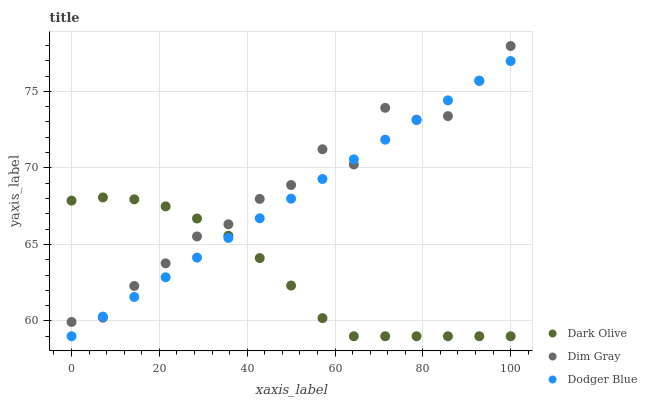Does Dark Olive have the minimum area under the curve?
Answer yes or no. Yes. Does Dim Gray have the maximum area under the curve?
Answer yes or no. Yes. Does Dodger Blue have the minimum area under the curve?
Answer yes or no. No. Does Dodger Blue have the maximum area under the curve?
Answer yes or no. No. Is Dodger Blue the smoothest?
Answer yes or no. Yes. Is Dim Gray the roughest?
Answer yes or no. Yes. Is Dark Olive the smoothest?
Answer yes or no. No. Is Dark Olive the roughest?
Answer yes or no. No. Does Dark Olive have the lowest value?
Answer yes or no. Yes. Does Dim Gray have the highest value?
Answer yes or no. Yes. Does Dodger Blue have the highest value?
Answer yes or no. No. Does Dark Olive intersect Dim Gray?
Answer yes or no. Yes. Is Dark Olive less than Dim Gray?
Answer yes or no. No. Is Dark Olive greater than Dim Gray?
Answer yes or no. No. 